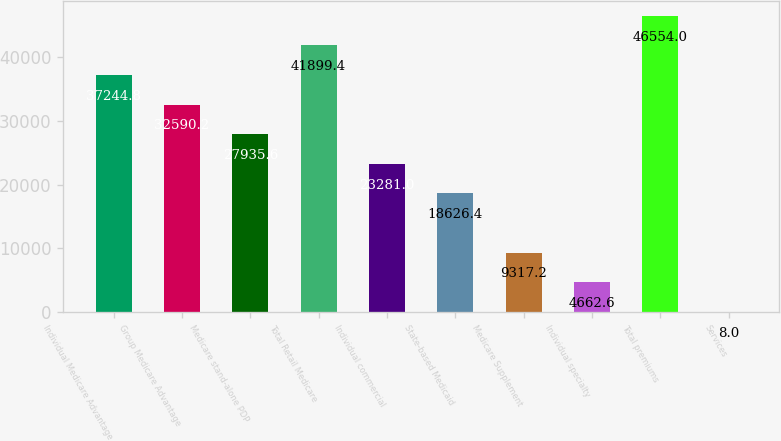Convert chart to OTSL. <chart><loc_0><loc_0><loc_500><loc_500><bar_chart><fcel>Individual Medicare Advantage<fcel>Group Medicare Advantage<fcel>Medicare stand-alone PDP<fcel>Total Retail Medicare<fcel>Individual commercial<fcel>State-based Medicaid<fcel>Medicare Supplement<fcel>Individual specialty<fcel>Total premiums<fcel>Services<nl><fcel>37244.8<fcel>32590.2<fcel>27935.6<fcel>41899.4<fcel>23281<fcel>18626.4<fcel>9317.2<fcel>4662.6<fcel>46554<fcel>8<nl></chart> 